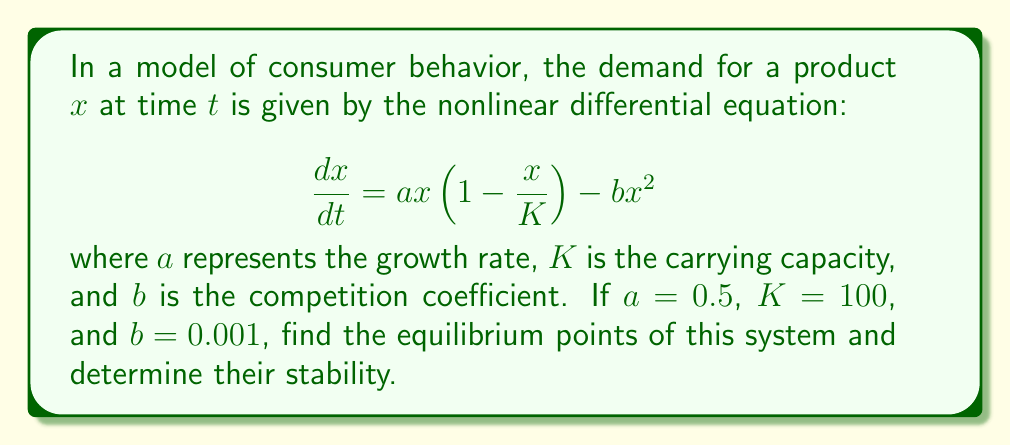Teach me how to tackle this problem. To solve this problem, we'll follow these steps:

1) First, we need to find the equilibrium points. These occur when $\frac{dx}{dt} = 0$.

2) Set up the equation:
   $$0 = ax(1-\frac{x}{K}) - bx^2$$

3) Substitute the given values:
   $$0 = 0.5x(1-\frac{x}{100}) - 0.001x^2$$

4) Simplify:
   $$0 = 0.5x - 0.005x^2 - 0.001x^2 = 0.5x - 0.006x^2$$

5) Factor out x:
   $$x(0.5 - 0.006x) = 0$$

6) Solve for x:
   $x = 0$ or $0.5 - 0.006x = 0$
   $x = 0$ or $x = \frac{0.5}{0.006} = 83.33$

7) To determine stability, we need to find $\frac{d}{dx}(\frac{dx}{dt})$ at each equilibrium point:

   $$\frac{d}{dx}(\frac{dx}{dt}) = a(1-\frac{2x}{K}) - 2bx$$
   $$= 0.5(1-\frac{2x}{100}) - 0.002x$$
   $$= 0.5 - 0.01x - 0.002x = 0.5 - 0.012x$$

8) Evaluate at $x = 0$:
   $0.5 - 0.012(0) = 0.5 > 0$, so $x = 0$ is unstable.

9) Evaluate at $x = 83.33$:
   $0.5 - 0.012(83.33) = -0.5 < 0$, so $x = 83.33$ is stable.
Answer: Equilibrium points: $x = 0$ (unstable) and $x = 83.33$ (stable) 